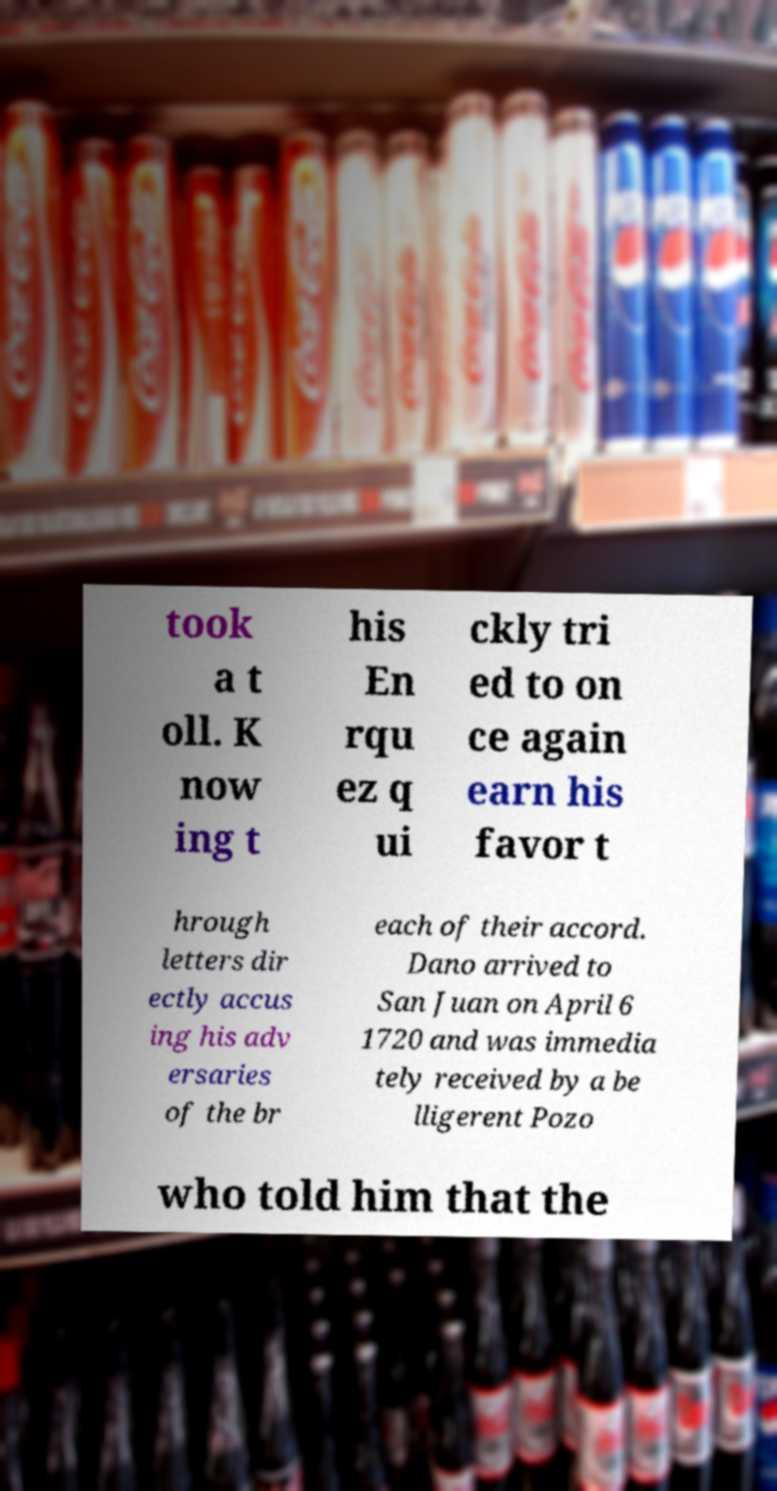Can you accurately transcribe the text from the provided image for me? took a t oll. K now ing t his En rqu ez q ui ckly tri ed to on ce again earn his favor t hrough letters dir ectly accus ing his adv ersaries of the br each of their accord. Dano arrived to San Juan on April 6 1720 and was immedia tely received by a be lligerent Pozo who told him that the 